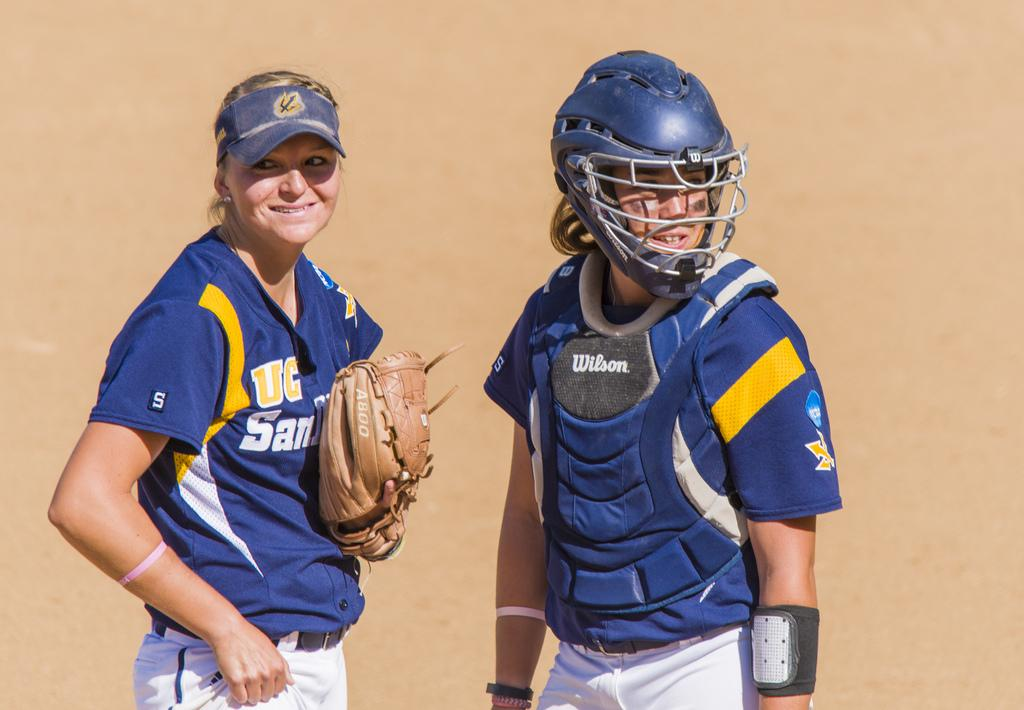Provide a one-sentence caption for the provided image. Two sports women, the left of whom has UC visible on their chest. 